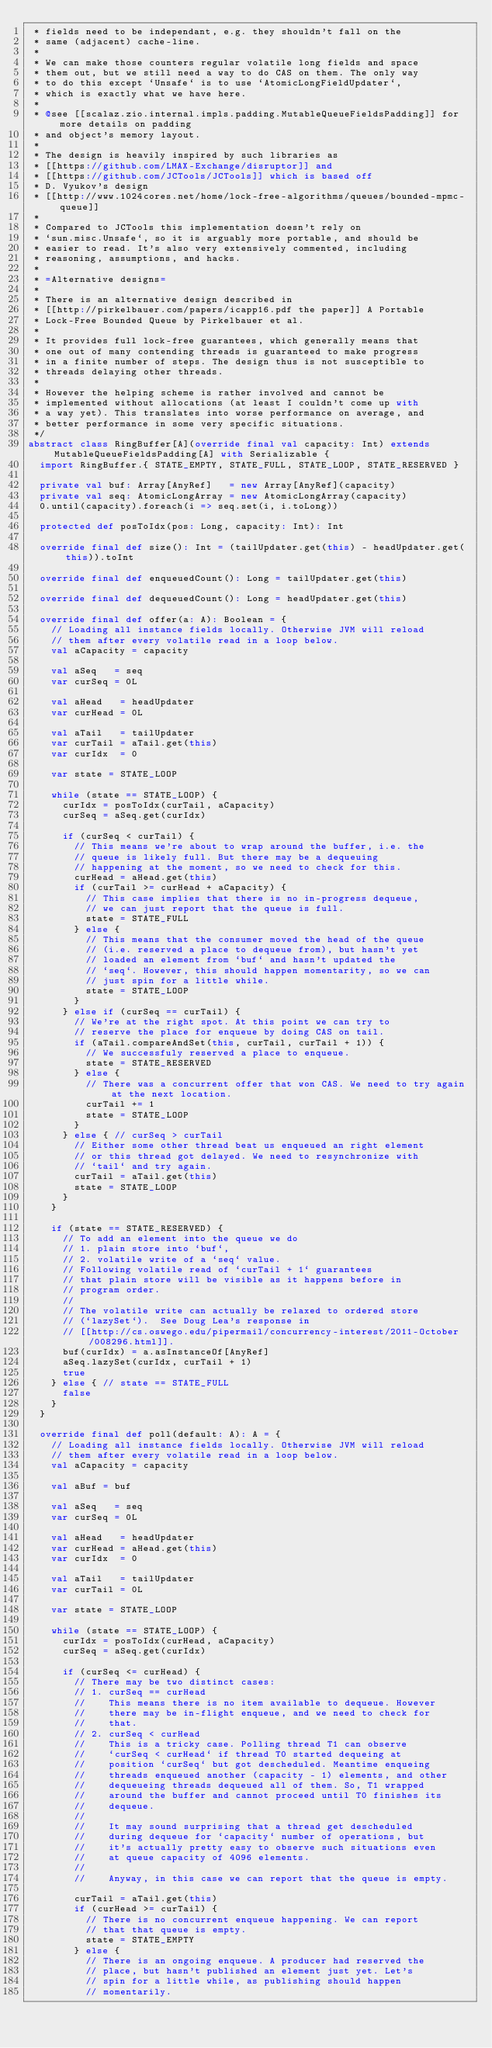<code> <loc_0><loc_0><loc_500><loc_500><_Scala_> * fields need to be independant, e.g. they shouldn't fall on the
 * same (adjacent) cache-line.
 *
 * We can make those counters regular volatile long fields and space
 * them out, but we still need a way to do CAS on them. The only way
 * to do this except `Unsafe` is to use `AtomicLongFieldUpdater`,
 * which is exactly what we have here.
 *
 * @see [[scalaz.zio.internal.impls.padding.MutableQueueFieldsPadding]] for more details on padding
 * and object's memory layout.
 *
 * The design is heavily inspired by such libraries as
 * [[https://github.com/LMAX-Exchange/disruptor]] and
 * [[https://github.com/JCTools/JCTools]] which is based off
 * D. Vyukov's design
 * [[http://www.1024cores.net/home/lock-free-algorithms/queues/bounded-mpmc-queue]]
 *
 * Compared to JCTools this implementation doesn't rely on
 * `sun.misc.Unsafe`, so it is arguably more portable, and should be
 * easier to read. It's also very extensively commented, including
 * reasoning, assumptions, and hacks.
 *
 * =Alternative designs=
 *
 * There is an alternative design described in
 * [[http://pirkelbauer.com/papers/icapp16.pdf the paper]] A Portable
 * Lock-Free Bounded Queue by Pirkelbauer et al.
 *
 * It provides full lock-free guarantees, which generally means that
 * one out of many contending threads is guaranteed to make progress
 * in a finite number of steps. The design thus is not susceptible to
 * threads delaying other threads.
 *
 * However the helping scheme is rather involved and cannot be
 * implemented without allocations (at least I couldn't come up with
 * a way yet). This translates into worse performance on average, and
 * better performance in some very specific situations.
 */
abstract class RingBuffer[A](override final val capacity: Int) extends MutableQueueFieldsPadding[A] with Serializable {
  import RingBuffer.{ STATE_EMPTY, STATE_FULL, STATE_LOOP, STATE_RESERVED }

  private val buf: Array[AnyRef]   = new Array[AnyRef](capacity)
  private val seq: AtomicLongArray = new AtomicLongArray(capacity)
  0.until(capacity).foreach(i => seq.set(i, i.toLong))

  protected def posToIdx(pos: Long, capacity: Int): Int

  override final def size(): Int = (tailUpdater.get(this) - headUpdater.get(this)).toInt

  override final def enqueuedCount(): Long = tailUpdater.get(this)

  override final def dequeuedCount(): Long = headUpdater.get(this)

  override final def offer(a: A): Boolean = {
    // Loading all instance fields locally. Otherwise JVM will reload
    // them after every volatile read in a loop below.
    val aCapacity = capacity

    val aSeq   = seq
    var curSeq = 0L

    val aHead   = headUpdater
    var curHead = 0L

    val aTail   = tailUpdater
    var curTail = aTail.get(this)
    var curIdx  = 0

    var state = STATE_LOOP

    while (state == STATE_LOOP) {
      curIdx = posToIdx(curTail, aCapacity)
      curSeq = aSeq.get(curIdx)

      if (curSeq < curTail) {
        // This means we're about to wrap around the buffer, i.e. the
        // queue is likely full. But there may be a dequeuing
        // happening at the moment, so we need to check for this.
        curHead = aHead.get(this)
        if (curTail >= curHead + aCapacity) {
          // This case implies that there is no in-progress dequeue,
          // we can just report that the queue is full.
          state = STATE_FULL
        } else {
          // This means that the consumer moved the head of the queue
          // (i.e. reserved a place to dequeue from), but hasn't yet
          // loaded an element from `buf` and hasn't updated the
          // `seq`. However, this should happen momentarity, so we can
          // just spin for a little while.
          state = STATE_LOOP
        }
      } else if (curSeq == curTail) {
        // We're at the right spot. At this point we can try to
        // reserve the place for enqueue by doing CAS on tail.
        if (aTail.compareAndSet(this, curTail, curTail + 1)) {
          // We successfuly reserved a place to enqueue.
          state = STATE_RESERVED
        } else {
          // There was a concurrent offer that won CAS. We need to try again at the next location.
          curTail += 1
          state = STATE_LOOP
        }
      } else { // curSeq > curTail
        // Either some other thread beat us enqueued an right element
        // or this thread got delayed. We need to resynchronize with
        // `tail` and try again.
        curTail = aTail.get(this)
        state = STATE_LOOP
      }
    }

    if (state == STATE_RESERVED) {
      // To add an element into the queue we do
      // 1. plain store into `buf`,
      // 2. volatile write of a `seq` value.
      // Following volatile read of `curTail + 1` guarantees
      // that plain store will be visible as it happens before in
      // program order.
      //
      // The volatile write can actually be relaxed to ordered store
      // (`lazySet`).  See Doug Lea's response in
      // [[http://cs.oswego.edu/pipermail/concurrency-interest/2011-October/008296.html]].
      buf(curIdx) = a.asInstanceOf[AnyRef]
      aSeq.lazySet(curIdx, curTail + 1)
      true
    } else { // state == STATE_FULL
      false
    }
  }

  override final def poll(default: A): A = {
    // Loading all instance fields locally. Otherwise JVM will reload
    // them after every volatile read in a loop below.
    val aCapacity = capacity

    val aBuf = buf

    val aSeq   = seq
    var curSeq = 0L

    val aHead   = headUpdater
    var curHead = aHead.get(this)
    var curIdx  = 0

    val aTail   = tailUpdater
    var curTail = 0L

    var state = STATE_LOOP

    while (state == STATE_LOOP) {
      curIdx = posToIdx(curHead, aCapacity)
      curSeq = aSeq.get(curIdx)

      if (curSeq <= curHead) {
        // There may be two distinct cases:
        // 1. curSeq == curHead
        //    This means there is no item available to dequeue. However
        //    there may be in-flight enqueue, and we need to check for
        //    that.
        // 2. curSeq < curHead
        //    This is a tricky case. Polling thread T1 can observe
        //    `curSeq < curHead` if thread T0 started dequeing at
        //    position `curSeq` but got descheduled. Meantime enqueing
        //    threads enqueued another (capacity - 1) elements, and other
        //    dequeueing threads dequeued all of them. So, T1 wrapped
        //    around the buffer and cannot proceed until T0 finishes its
        //    dequeue.
        //
        //    It may sound surprising that a thread get descheduled
        //    during dequeue for `capacity` number of operations, but
        //    it's actually pretty easy to observe such situations even
        //    at queue capacity of 4096 elements.
        //
        //    Anyway, in this case we can report that the queue is empty.

        curTail = aTail.get(this)
        if (curHead >= curTail) {
          // There is no concurrent enqueue happening. We can report
          // that that queue is empty.
          state = STATE_EMPTY
        } else {
          // There is an ongoing enqueue. A producer had reserved the
          // place, but hasn't published an element just yet. Let's
          // spin for a little while, as publishing should happen
          // momentarily.</code> 